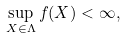<formula> <loc_0><loc_0><loc_500><loc_500>\sup _ { X \in \Lambda } f ( X ) < \infty ,</formula> 